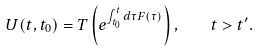Convert formula to latex. <formula><loc_0><loc_0><loc_500><loc_500>U ( t , t _ { 0 } ) = T \left ( e ^ { \int _ { t _ { 0 } } ^ { t } d \tau F ( \tau ) } \right ) , \quad t > t ^ { \prime } .</formula> 